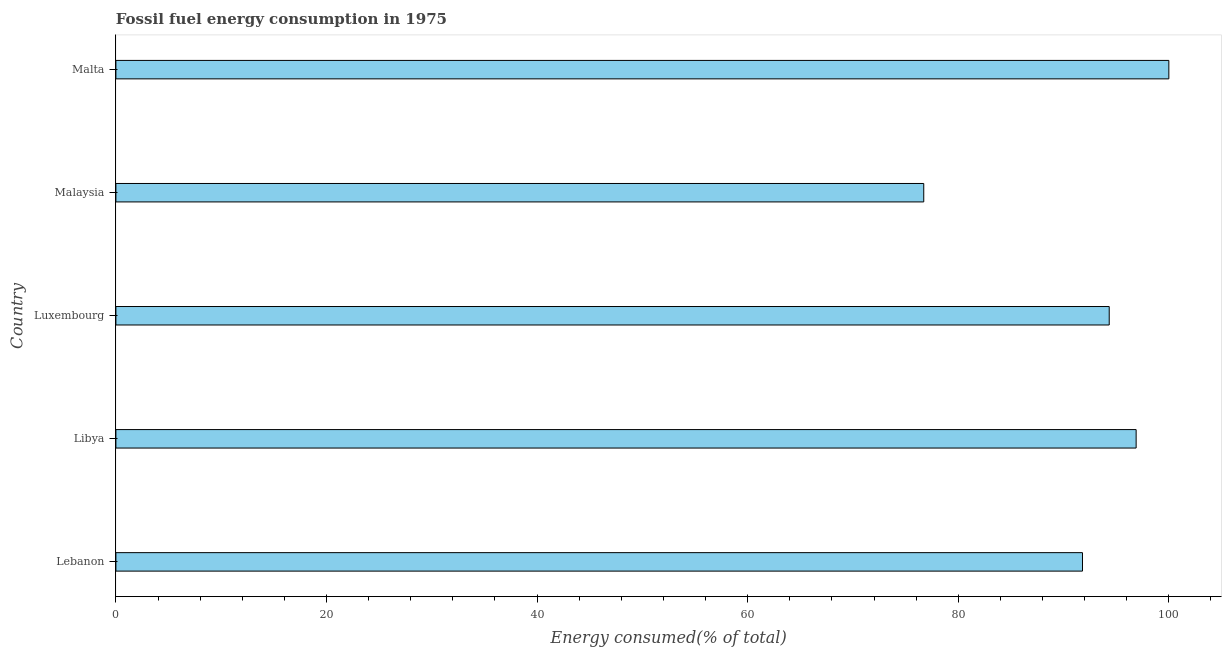Does the graph contain any zero values?
Ensure brevity in your answer.  No. Does the graph contain grids?
Your answer should be compact. No. What is the title of the graph?
Make the answer very short. Fossil fuel energy consumption in 1975. What is the label or title of the X-axis?
Your response must be concise. Energy consumed(% of total). What is the fossil fuel energy consumption in Luxembourg?
Offer a terse response. 94.34. Across all countries, what is the maximum fossil fuel energy consumption?
Ensure brevity in your answer.  100. Across all countries, what is the minimum fossil fuel energy consumption?
Offer a very short reply. 76.72. In which country was the fossil fuel energy consumption maximum?
Give a very brief answer. Malta. In which country was the fossil fuel energy consumption minimum?
Your answer should be compact. Malaysia. What is the sum of the fossil fuel energy consumption?
Offer a very short reply. 459.75. What is the difference between the fossil fuel energy consumption in Lebanon and Libya?
Ensure brevity in your answer.  -5.09. What is the average fossil fuel energy consumption per country?
Your answer should be compact. 91.95. What is the median fossil fuel energy consumption?
Make the answer very short. 94.34. What is the ratio of the fossil fuel energy consumption in Luxembourg to that in Malta?
Offer a terse response. 0.94. Is the difference between the fossil fuel energy consumption in Libya and Luxembourg greater than the difference between any two countries?
Your response must be concise. No. What is the difference between the highest and the second highest fossil fuel energy consumption?
Make the answer very short. 3.11. What is the difference between the highest and the lowest fossil fuel energy consumption?
Offer a terse response. 23.28. In how many countries, is the fossil fuel energy consumption greater than the average fossil fuel energy consumption taken over all countries?
Your answer should be very brief. 3. How many bars are there?
Your response must be concise. 5. What is the Energy consumed(% of total) in Lebanon?
Keep it short and to the point. 91.8. What is the Energy consumed(% of total) of Libya?
Keep it short and to the point. 96.89. What is the Energy consumed(% of total) of Luxembourg?
Your answer should be compact. 94.34. What is the Energy consumed(% of total) in Malaysia?
Ensure brevity in your answer.  76.72. What is the difference between the Energy consumed(% of total) in Lebanon and Libya?
Ensure brevity in your answer.  -5.1. What is the difference between the Energy consumed(% of total) in Lebanon and Luxembourg?
Ensure brevity in your answer.  -2.54. What is the difference between the Energy consumed(% of total) in Lebanon and Malaysia?
Provide a succinct answer. 15.07. What is the difference between the Energy consumed(% of total) in Lebanon and Malta?
Provide a short and direct response. -8.2. What is the difference between the Energy consumed(% of total) in Libya and Luxembourg?
Offer a very short reply. 2.56. What is the difference between the Energy consumed(% of total) in Libya and Malaysia?
Your answer should be very brief. 20.17. What is the difference between the Energy consumed(% of total) in Libya and Malta?
Make the answer very short. -3.11. What is the difference between the Energy consumed(% of total) in Luxembourg and Malaysia?
Your response must be concise. 17.61. What is the difference between the Energy consumed(% of total) in Luxembourg and Malta?
Your answer should be compact. -5.66. What is the difference between the Energy consumed(% of total) in Malaysia and Malta?
Offer a terse response. -23.28. What is the ratio of the Energy consumed(% of total) in Lebanon to that in Libya?
Give a very brief answer. 0.95. What is the ratio of the Energy consumed(% of total) in Lebanon to that in Malaysia?
Keep it short and to the point. 1.2. What is the ratio of the Energy consumed(% of total) in Lebanon to that in Malta?
Make the answer very short. 0.92. What is the ratio of the Energy consumed(% of total) in Libya to that in Malaysia?
Offer a terse response. 1.26. What is the ratio of the Energy consumed(% of total) in Luxembourg to that in Malaysia?
Offer a terse response. 1.23. What is the ratio of the Energy consumed(% of total) in Luxembourg to that in Malta?
Your response must be concise. 0.94. What is the ratio of the Energy consumed(% of total) in Malaysia to that in Malta?
Your answer should be very brief. 0.77. 